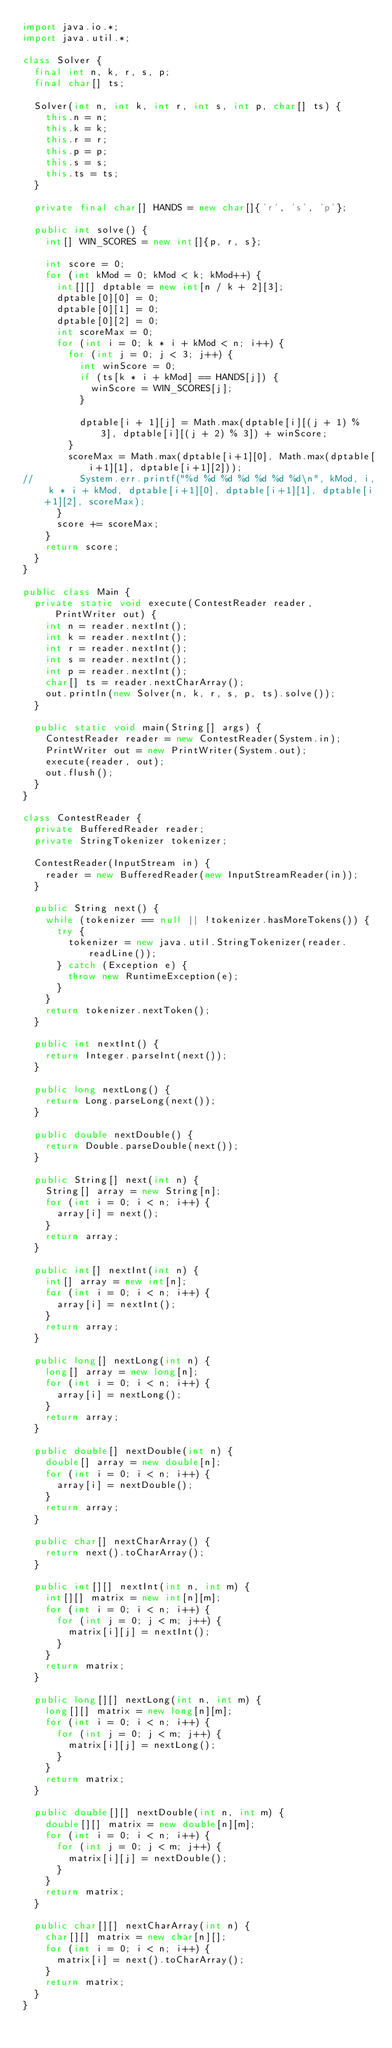Convert code to text. <code><loc_0><loc_0><loc_500><loc_500><_Java_>import java.io.*;
import java.util.*;

class Solver {
  final int n, k, r, s, p;
  final char[] ts;
  
  Solver(int n, int k, int r, int s, int p, char[] ts) {
    this.n = n;
    this.k = k;
    this.r = r;
    this.p = p;
    this.s = s;
    this.ts = ts;
  }
  
  private final char[] HANDS = new char[]{'r', 's', 'p'};
  
  public int solve() {
    int[] WIN_SCORES = new int[]{p, r, s};
    
    int score = 0;
    for (int kMod = 0; kMod < k; kMod++) {
      int[][] dptable = new int[n / k + 2][3];
      dptable[0][0] = 0;
      dptable[0][1] = 0;
      dptable[0][2] = 0;
      int scoreMax = 0;
      for (int i = 0; k * i + kMod < n; i++) {
        for (int j = 0; j < 3; j++) {
          int winScore = 0;
          if (ts[k * i + kMod] == HANDS[j]) {
            winScore = WIN_SCORES[j];
          }
          
          dptable[i + 1][j] = Math.max(dptable[i][(j + 1) % 3], dptable[i][(j + 2) % 3]) + winScore;
        }
        scoreMax = Math.max(dptable[i+1][0], Math.max(dptable[i+1][1], dptable[i+1][2]));
//        System.err.printf("%d %d %d %d %d %d %d\n", kMod, i, k * i + kMod, dptable[i+1][0], dptable[i+1][1], dptable[i+1][2], scoreMax);
      }
      score += scoreMax;
    }
    return score;
  }
}

public class Main {
  private static void execute(ContestReader reader, PrintWriter out) {
    int n = reader.nextInt();
    int k = reader.nextInt();
    int r = reader.nextInt();
    int s = reader.nextInt();
    int p = reader.nextInt();
    char[] ts = reader.nextCharArray();
    out.println(new Solver(n, k, r, s, p, ts).solve());
  }
  
  public static void main(String[] args) {
    ContestReader reader = new ContestReader(System.in);
    PrintWriter out = new PrintWriter(System.out);
    execute(reader, out);
    out.flush();
  }
}

class ContestReader {
  private BufferedReader reader;
  private StringTokenizer tokenizer;
  
  ContestReader(InputStream in) {
    reader = new BufferedReader(new InputStreamReader(in));
  }
  
  public String next() {
    while (tokenizer == null || !tokenizer.hasMoreTokens()) {
      try {
        tokenizer = new java.util.StringTokenizer(reader.readLine());
      } catch (Exception e) {
        throw new RuntimeException(e);
      }
    }
    return tokenizer.nextToken();
  }
  
  public int nextInt() {
    return Integer.parseInt(next());
  }
  
  public long nextLong() {
    return Long.parseLong(next());
  }
  
  public double nextDouble() {
    return Double.parseDouble(next());
  }
  
  public String[] next(int n) {
    String[] array = new String[n];
    for (int i = 0; i < n; i++) {
      array[i] = next();
    }
    return array;
  }
  
  public int[] nextInt(int n) {
    int[] array = new int[n];
    for (int i = 0; i < n; i++) {
      array[i] = nextInt();
    }
    return array;
  }
  
  public long[] nextLong(int n) {
    long[] array = new long[n];
    for (int i = 0; i < n; i++) {
      array[i] = nextLong();
    }
    return array;
  }
  
  public double[] nextDouble(int n) {
    double[] array = new double[n];
    for (int i = 0; i < n; i++) {
      array[i] = nextDouble();
    }
    return array;
  }
  
  public char[] nextCharArray() {
    return next().toCharArray();
  }
  
  public int[][] nextInt(int n, int m) {
    int[][] matrix = new int[n][m];
    for (int i = 0; i < n; i++) {
      for (int j = 0; j < m; j++) {
        matrix[i][j] = nextInt();
      }
    }
    return matrix;
  }
  
  public long[][] nextLong(int n, int m) {
    long[][] matrix = new long[n][m];
    for (int i = 0; i < n; i++) {
      for (int j = 0; j < m; j++) {
        matrix[i][j] = nextLong();
      }
    }
    return matrix;
  }
  
  public double[][] nextDouble(int n, int m) {
    double[][] matrix = new double[n][m];
    for (int i = 0; i < n; i++) {
      for (int j = 0; j < m; j++) {
        matrix[i][j] = nextDouble();
      }
    }
    return matrix;
  }
  
  public char[][] nextCharArray(int n) {
    char[][] matrix = new char[n][];
    for (int i = 0; i < n; i++) {
      matrix[i] = next().toCharArray();
    }
    return matrix;
  }
}
</code> 